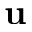Convert formula to latex. <formula><loc_0><loc_0><loc_500><loc_500>{ \mathbf u }</formula> 